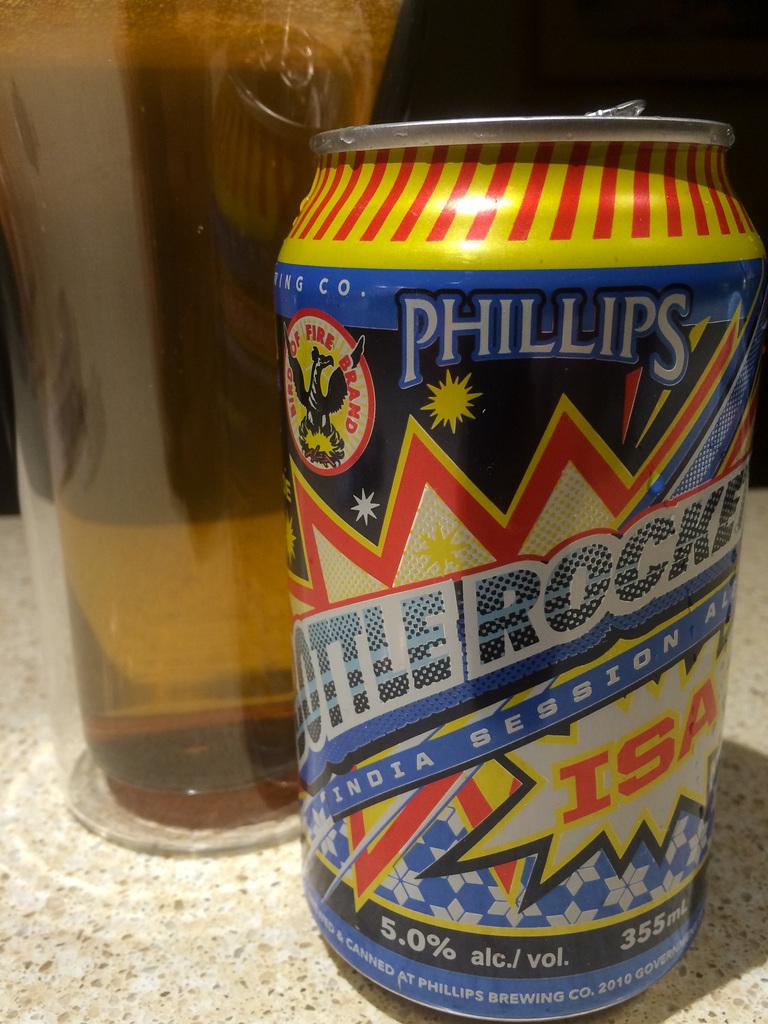<image>
Render a clear and concise summary of the photo. the letters ISAn are on a can of beer 